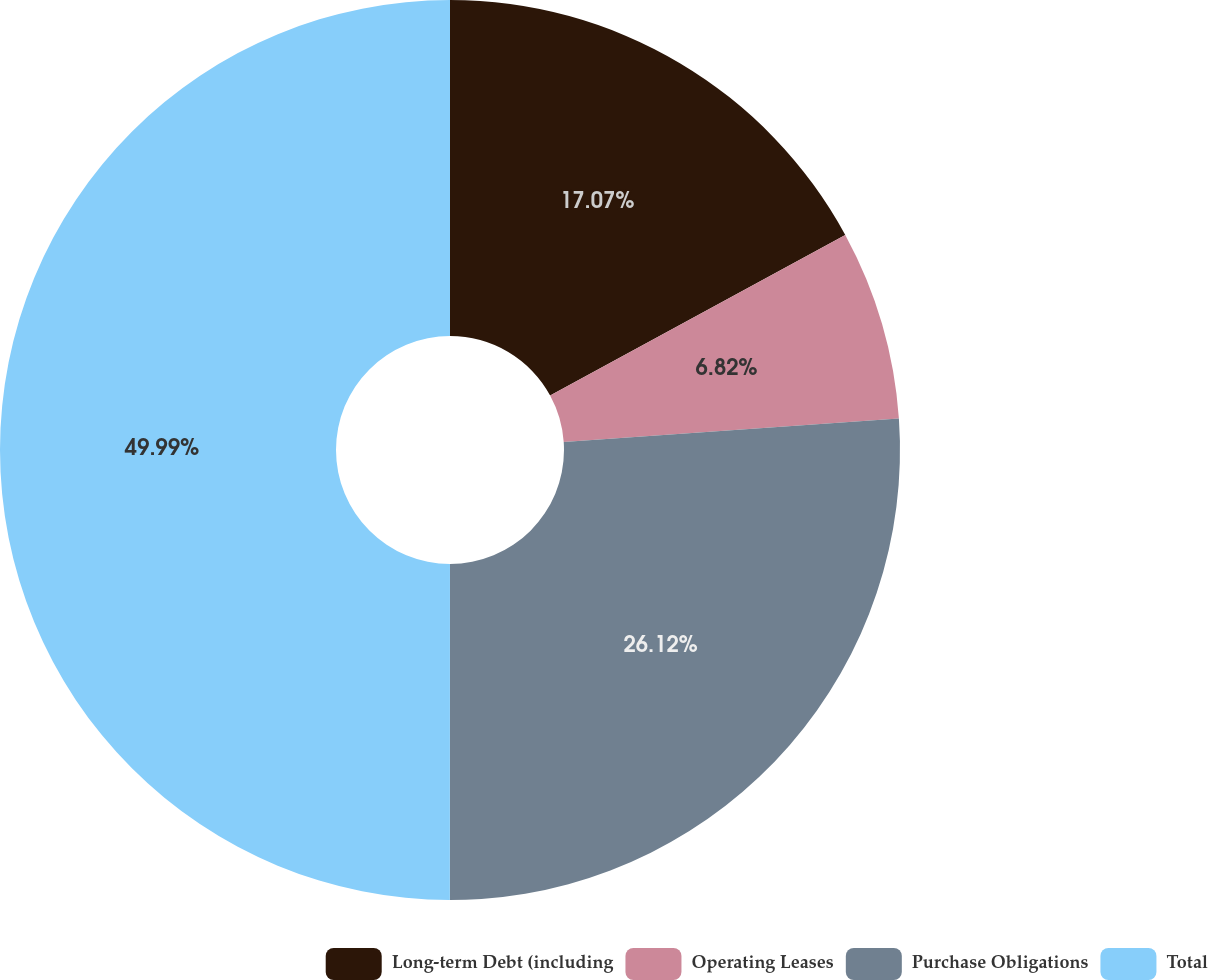Convert chart to OTSL. <chart><loc_0><loc_0><loc_500><loc_500><pie_chart><fcel>Long-term Debt (including<fcel>Operating Leases<fcel>Purchase Obligations<fcel>Total<nl><fcel>17.07%<fcel>6.82%<fcel>26.12%<fcel>50.0%<nl></chart> 